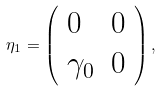Convert formula to latex. <formula><loc_0><loc_0><loc_500><loc_500>\eta _ { 1 } = \left ( \begin{array} { l l } 0 & 0 \\ \gamma _ { 0 } & 0 \end{array} \right ) ,</formula> 